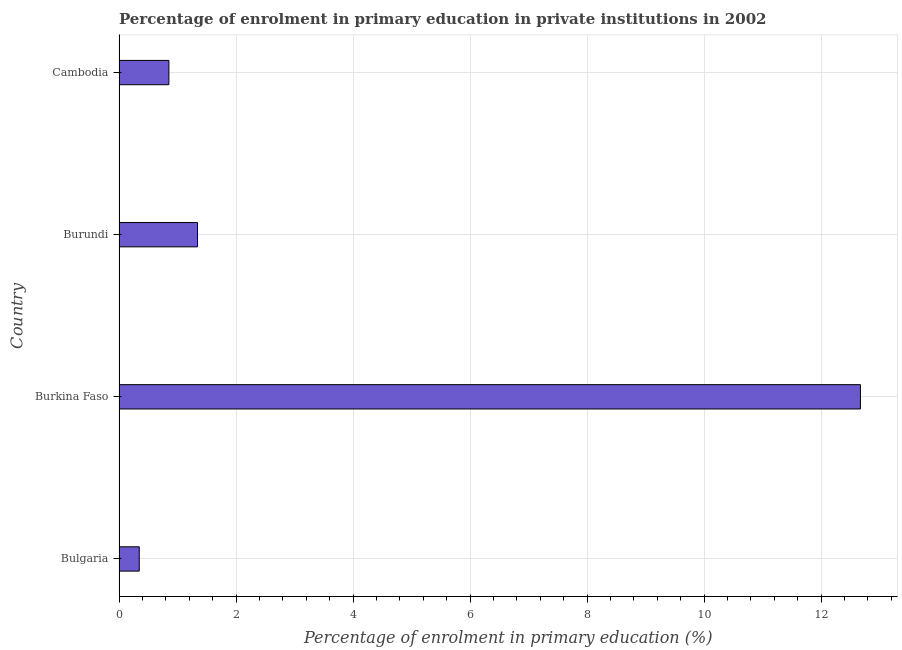Does the graph contain any zero values?
Offer a very short reply. No. What is the title of the graph?
Give a very brief answer. Percentage of enrolment in primary education in private institutions in 2002. What is the label or title of the X-axis?
Offer a terse response. Percentage of enrolment in primary education (%). What is the enrolment percentage in primary education in Burkina Faso?
Offer a terse response. 12.67. Across all countries, what is the maximum enrolment percentage in primary education?
Make the answer very short. 12.67. Across all countries, what is the minimum enrolment percentage in primary education?
Provide a succinct answer. 0.35. In which country was the enrolment percentage in primary education maximum?
Your response must be concise. Burkina Faso. What is the sum of the enrolment percentage in primary education?
Offer a terse response. 15.21. What is the difference between the enrolment percentage in primary education in Bulgaria and Burundi?
Ensure brevity in your answer.  -1. What is the average enrolment percentage in primary education per country?
Give a very brief answer. 3.8. What is the median enrolment percentage in primary education?
Provide a succinct answer. 1.1. What is the ratio of the enrolment percentage in primary education in Burundi to that in Cambodia?
Provide a short and direct response. 1.57. Is the enrolment percentage in primary education in Burkina Faso less than that in Cambodia?
Keep it short and to the point. No. Is the difference between the enrolment percentage in primary education in Burkina Faso and Cambodia greater than the difference between any two countries?
Your answer should be compact. No. What is the difference between the highest and the second highest enrolment percentage in primary education?
Give a very brief answer. 11.33. Is the sum of the enrolment percentage in primary education in Bulgaria and Burkina Faso greater than the maximum enrolment percentage in primary education across all countries?
Make the answer very short. Yes. What is the difference between the highest and the lowest enrolment percentage in primary education?
Offer a very short reply. 12.33. In how many countries, is the enrolment percentage in primary education greater than the average enrolment percentage in primary education taken over all countries?
Make the answer very short. 1. How many bars are there?
Provide a succinct answer. 4. Are all the bars in the graph horizontal?
Keep it short and to the point. Yes. How many countries are there in the graph?
Your answer should be very brief. 4. Are the values on the major ticks of X-axis written in scientific E-notation?
Your answer should be compact. No. What is the Percentage of enrolment in primary education (%) in Bulgaria?
Your answer should be very brief. 0.35. What is the Percentage of enrolment in primary education (%) in Burkina Faso?
Your response must be concise. 12.67. What is the Percentage of enrolment in primary education (%) in Burundi?
Keep it short and to the point. 1.34. What is the Percentage of enrolment in primary education (%) in Cambodia?
Ensure brevity in your answer.  0.85. What is the difference between the Percentage of enrolment in primary education (%) in Bulgaria and Burkina Faso?
Your answer should be compact. -12.33. What is the difference between the Percentage of enrolment in primary education (%) in Bulgaria and Burundi?
Your answer should be compact. -1. What is the difference between the Percentage of enrolment in primary education (%) in Bulgaria and Cambodia?
Make the answer very short. -0.51. What is the difference between the Percentage of enrolment in primary education (%) in Burkina Faso and Burundi?
Your response must be concise. 11.33. What is the difference between the Percentage of enrolment in primary education (%) in Burkina Faso and Cambodia?
Provide a succinct answer. 11.82. What is the difference between the Percentage of enrolment in primary education (%) in Burundi and Cambodia?
Provide a short and direct response. 0.49. What is the ratio of the Percentage of enrolment in primary education (%) in Bulgaria to that in Burkina Faso?
Offer a very short reply. 0.03. What is the ratio of the Percentage of enrolment in primary education (%) in Bulgaria to that in Burundi?
Your answer should be very brief. 0.26. What is the ratio of the Percentage of enrolment in primary education (%) in Bulgaria to that in Cambodia?
Keep it short and to the point. 0.41. What is the ratio of the Percentage of enrolment in primary education (%) in Burkina Faso to that in Burundi?
Offer a very short reply. 9.45. What is the ratio of the Percentage of enrolment in primary education (%) in Burkina Faso to that in Cambodia?
Your answer should be compact. 14.88. What is the ratio of the Percentage of enrolment in primary education (%) in Burundi to that in Cambodia?
Provide a succinct answer. 1.57. 